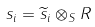Convert formula to latex. <formula><loc_0><loc_0><loc_500><loc_500>s _ { i } = \widetilde { s } _ { i } \otimes _ { S } R</formula> 